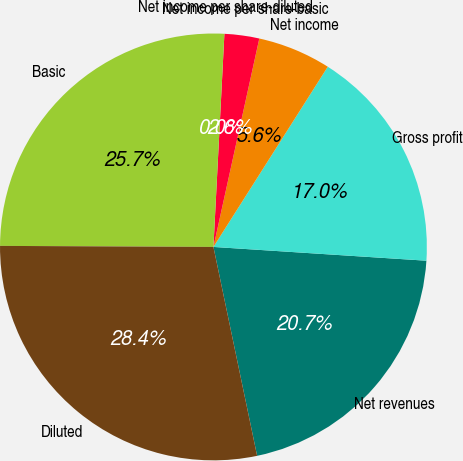Convert chart to OTSL. <chart><loc_0><loc_0><loc_500><loc_500><pie_chart><fcel>Net revenues<fcel>Gross profit<fcel>Net income<fcel>Net income per share-basic<fcel>Net income per share-diluted<fcel>Basic<fcel>Diluted<nl><fcel>20.69%<fcel>17.03%<fcel>5.55%<fcel>2.63%<fcel>0.0%<fcel>25.74%<fcel>28.36%<nl></chart> 